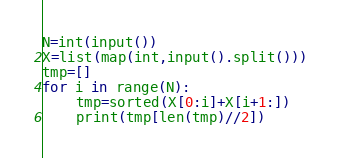Convert code to text. <code><loc_0><loc_0><loc_500><loc_500><_Python_>N=int(input())
X=list(map(int,input().split()))
tmp=[]
for i in range(N):
    tmp=sorted(X[0:i]+X[i+1:])
    print(tmp[len(tmp)//2])
</code> 